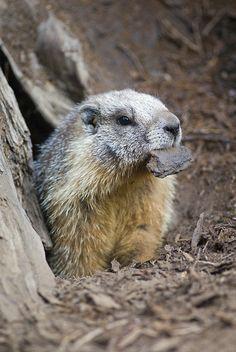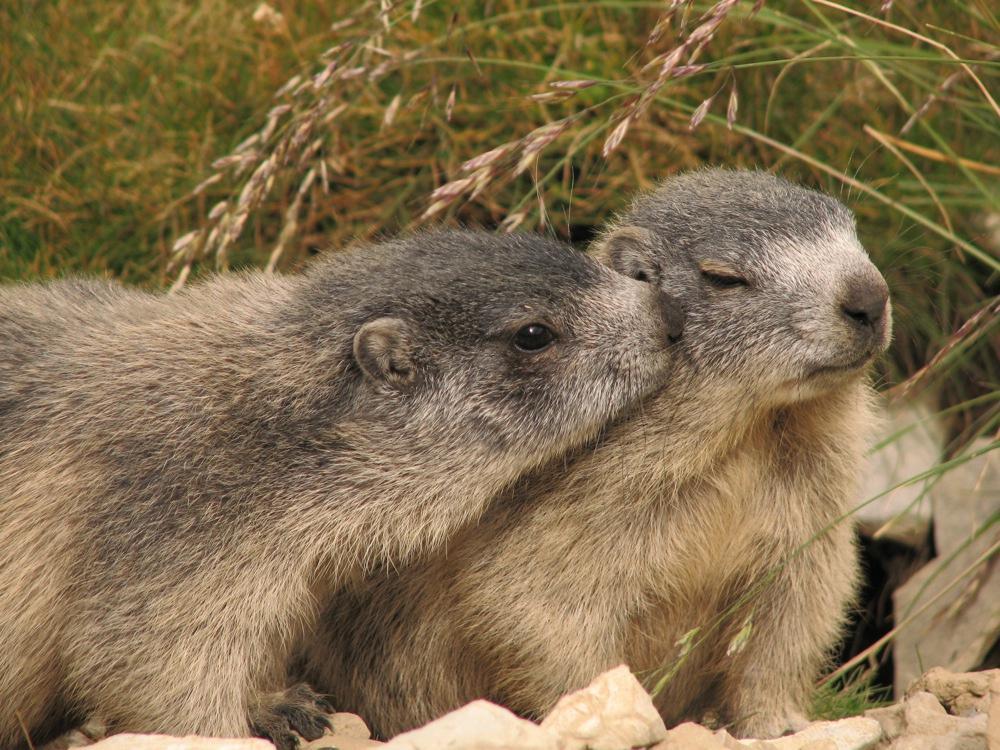The first image is the image on the left, the second image is the image on the right. For the images shown, is this caption "There are two marmots, and both stand upright with front paws dangling." true? Answer yes or no. No. The first image is the image on the left, the second image is the image on the right. For the images shown, is this caption "At least one animal in the image on the left is standing near a piece of manmade equipment." true? Answer yes or no. No. 